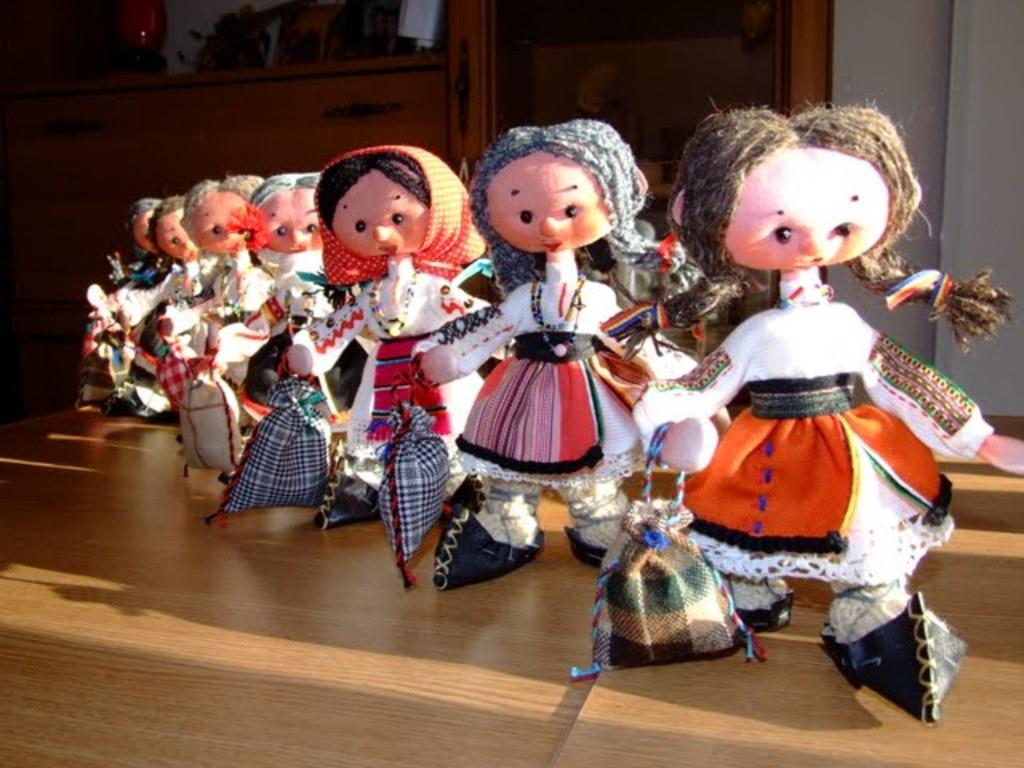What objects can be seen on the table in the image? There are toys on the table in the image. What structure is located behind the table? There is a cupboard with racks behind the table. What can be found on the cupboard's racks? There are items on the cupboard's racks. How many thumbs are visible on the toys in the image? There are no thumbs visible on the toys in the image, as they are inanimate objects. 